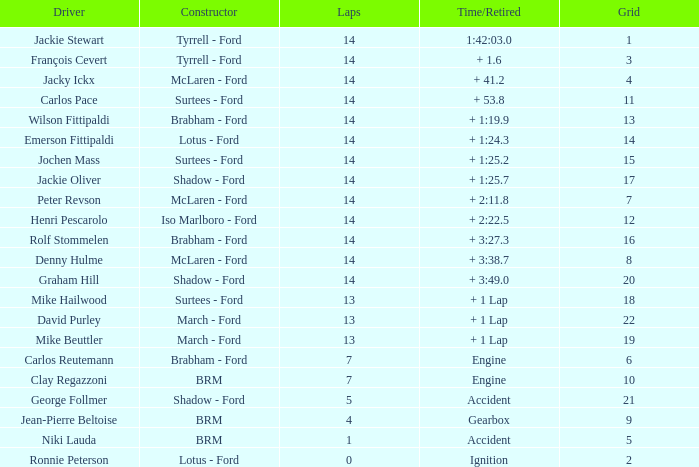What is the minimum lap count for a grid bigger than 16 and with a time/retired of + 3:2 None. 